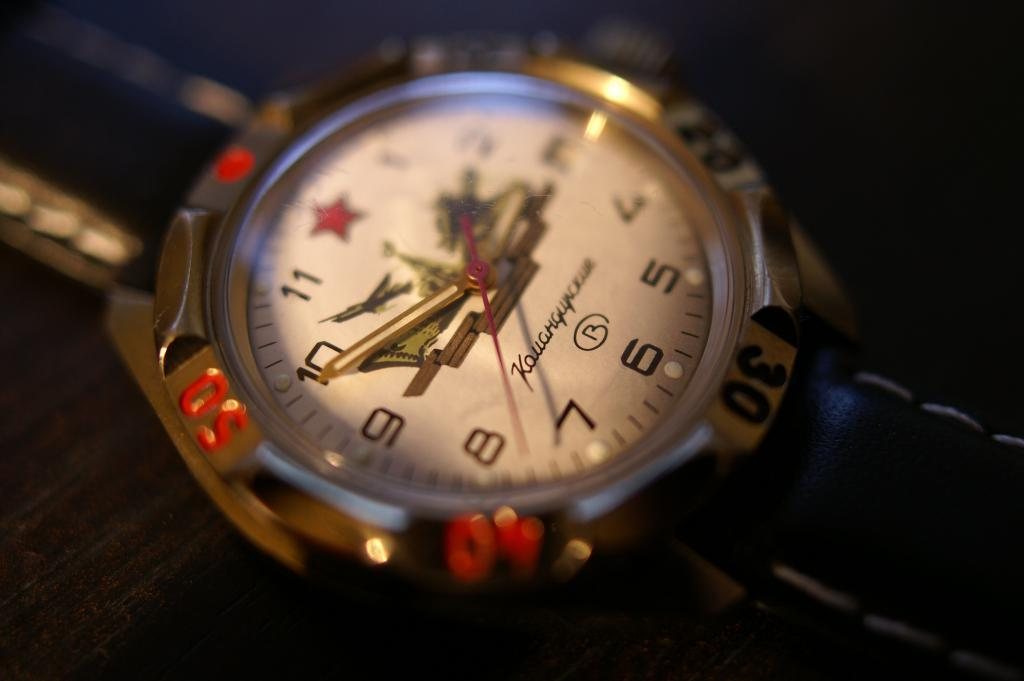<image>
Render a clear and concise summary of the photo. Clock that says 2:49 and has text in different language with letter B on it. 